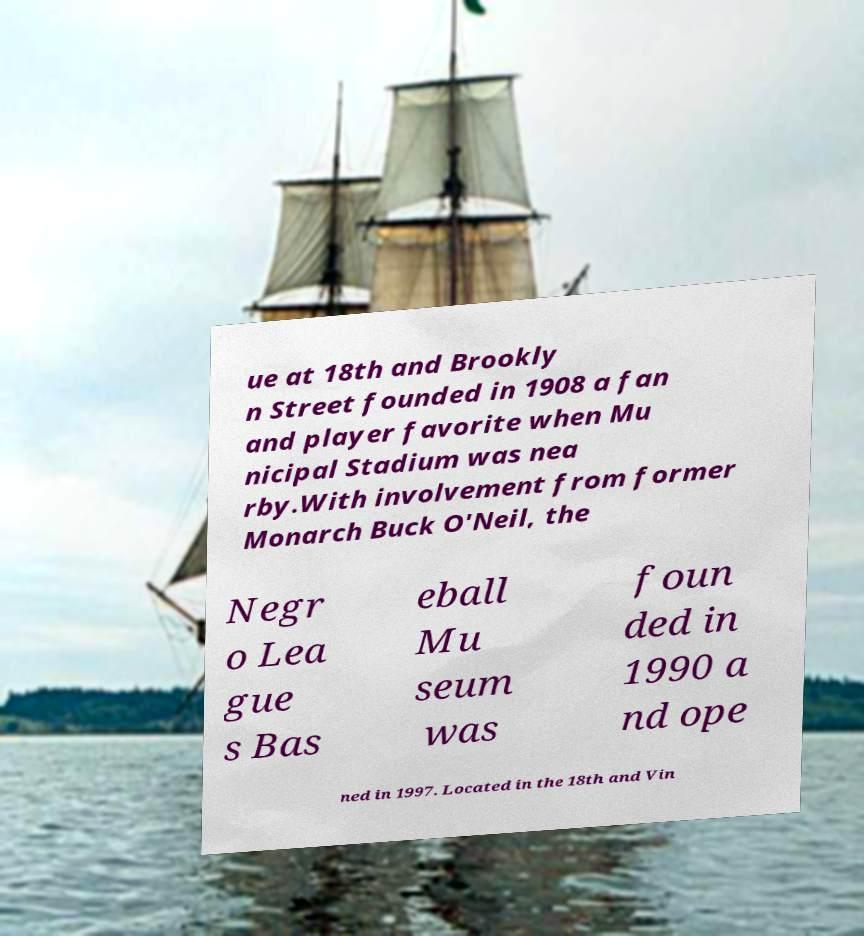Can you accurately transcribe the text from the provided image for me? ue at 18th and Brookly n Street founded in 1908 a fan and player favorite when Mu nicipal Stadium was nea rby.With involvement from former Monarch Buck O'Neil, the Negr o Lea gue s Bas eball Mu seum was foun ded in 1990 a nd ope ned in 1997. Located in the 18th and Vin 